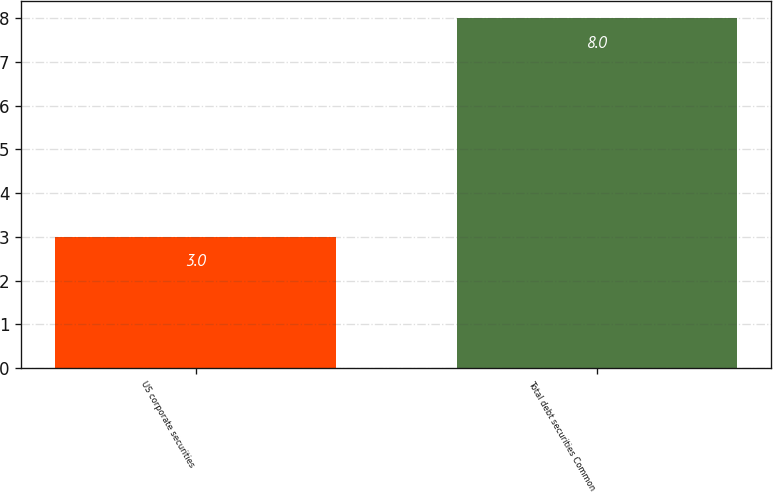<chart> <loc_0><loc_0><loc_500><loc_500><bar_chart><fcel>US corporate securities<fcel>Total debt securities Common<nl><fcel>3<fcel>8<nl></chart> 